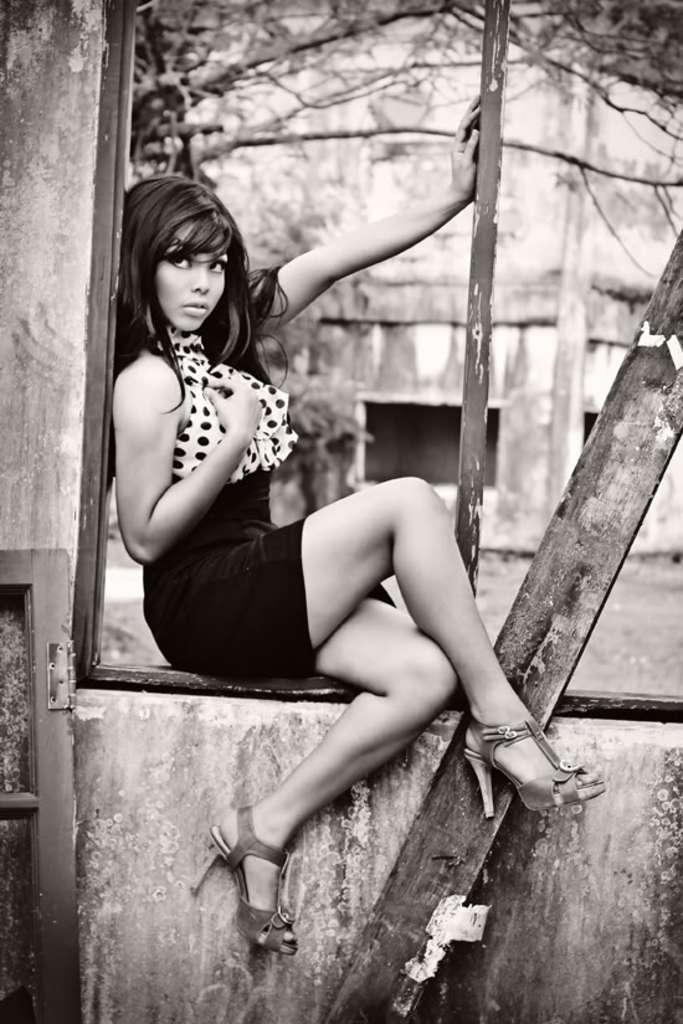Could you give a brief overview of what you see in this image? This is a black and white pic. We can see a girl is sitting on the window door. At the bottom we can see wooden objects. In the background there is a tree and a building. 